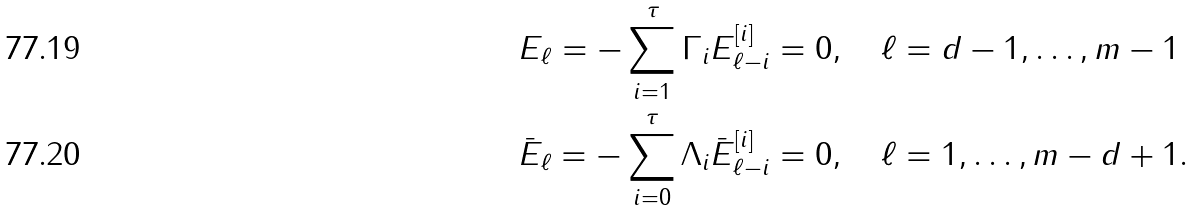Convert formula to latex. <formula><loc_0><loc_0><loc_500><loc_500>E _ { \ell } = - \sum _ { i = 1 } ^ { \tau } \Gamma _ { i } E _ { \ell - i } ^ { [ i ] } & = 0 , \quad \ell = d - 1 , \dots , m - 1 \\ \bar { E } _ { \ell } = - \sum _ { i = 0 } ^ { \tau } \Lambda _ { i } \bar { E } _ { \ell - i } ^ { [ i ] } & = 0 , \quad \ell = 1 , \dots , m - d + 1 .</formula> 